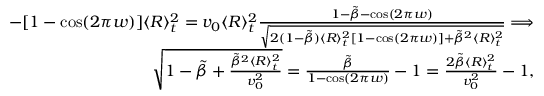<formula> <loc_0><loc_0><loc_500><loc_500>\begin{array} { r l r } & { - [ 1 - \cos ( 2 \pi w ) ] \langle R \rangle _ { t } ^ { 2 } = v _ { 0 } \langle R \rangle _ { t } ^ { 2 } \frac { 1 - \tilde { \beta } - \cos ( 2 \pi w ) } { \sqrt { 2 ( 1 - \tilde { \beta } ) \langle R \rangle _ { t } ^ { 2 } [ 1 - \cos ( 2 \pi w ) ] + \tilde { \beta } ^ { 2 } \langle R \rangle _ { t } ^ { 2 } } } \Longrightarrow } \\ & { \sqrt { 1 - \tilde { \beta } + \frac { \tilde { \beta } ^ { 2 } \langle R \rangle _ { t } ^ { 2 } } { v _ { 0 } ^ { 2 } } } = \frac { \tilde { \beta } } { 1 - \cos ( 2 \pi w ) } - 1 = \frac { 2 \tilde { \beta } \langle R \rangle _ { t } ^ { 2 } } { v _ { 0 } ^ { 2 } } - 1 , } \end{array}</formula> 